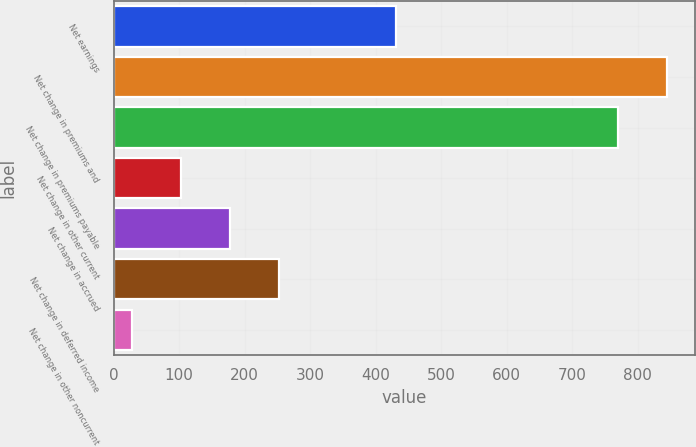Convert chart to OTSL. <chart><loc_0><loc_0><loc_500><loc_500><bar_chart><fcel>Net earnings<fcel>Net change in premiums and<fcel>Net change in premiums payable<fcel>Net change in other current<fcel>Net change in accrued<fcel>Net change in deferred income<fcel>Net change in other noncurrent<nl><fcel>430.3<fcel>844.97<fcel>770<fcel>102.47<fcel>177.44<fcel>252.41<fcel>27.5<nl></chart> 